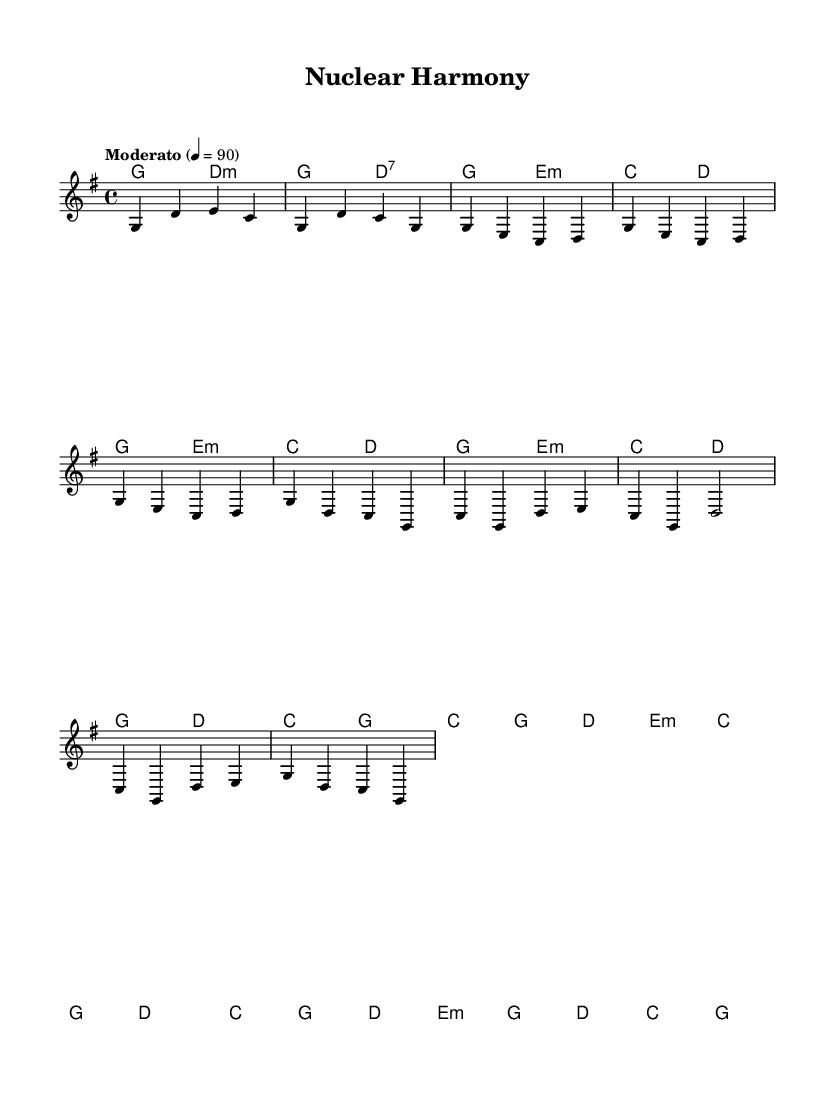What is the key signature of this music? The key signature is G major. This can be identified by looking at the sharp signs, and G major has one sharp (F#).
Answer: G major What is the time signature of this music? The time signature is 4/4. This is indicated at the beginning of the score, showing there are four beats per measure.
Answer: 4/4 What is the tempo marking for this piece? The tempo marking is "Moderato" at a speed of 90 beats per minute. The word "Moderato" indicates a moderate tempo.
Answer: Moderato How many measures are there in the chorus? There are four measures in the chorus section. This can be counted by examining the number of measures specifically labeled as part of the chorus.
Answer: 4 What are the primary chords used in the verse? The primary chords used in the verse are G, E minor, C, and D. This can be determined by noting the chord changes provided during that section of the score.
Answer: G, E minor, C, D What is the rest value in the chorus section? The rest value in the chorus section is half note (d1), which can be observed in the notation representing silence for that specific duration.
Answer: Half note What is the overall theme of this piece? The overall theme is the harmony between nature and energy solutions, as suggested by the title "Nuclear Harmony." This title implies a blending of natural and modern technology concepts.
Answer: Harmony between nature and modern energy solutions 